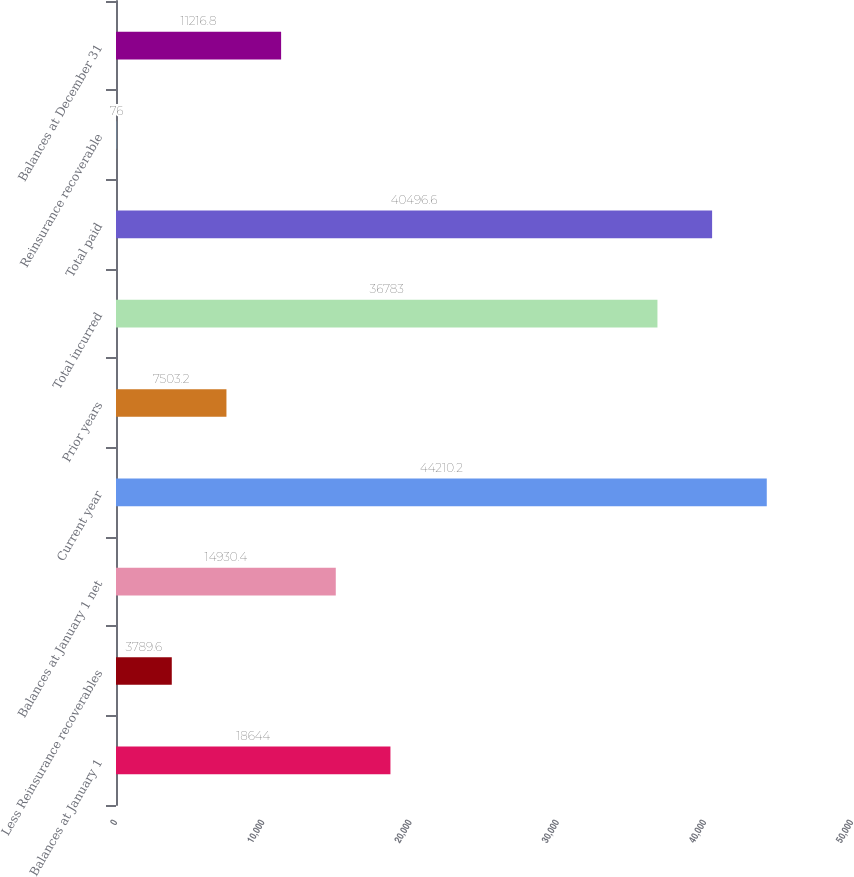Convert chart. <chart><loc_0><loc_0><loc_500><loc_500><bar_chart><fcel>Balances at January 1<fcel>Less Reinsurance recoverables<fcel>Balances at January 1 net<fcel>Current year<fcel>Prior years<fcel>Total incurred<fcel>Total paid<fcel>Reinsurance recoverable<fcel>Balances at December 31<nl><fcel>18644<fcel>3789.6<fcel>14930.4<fcel>44210.2<fcel>7503.2<fcel>36783<fcel>40496.6<fcel>76<fcel>11216.8<nl></chart> 